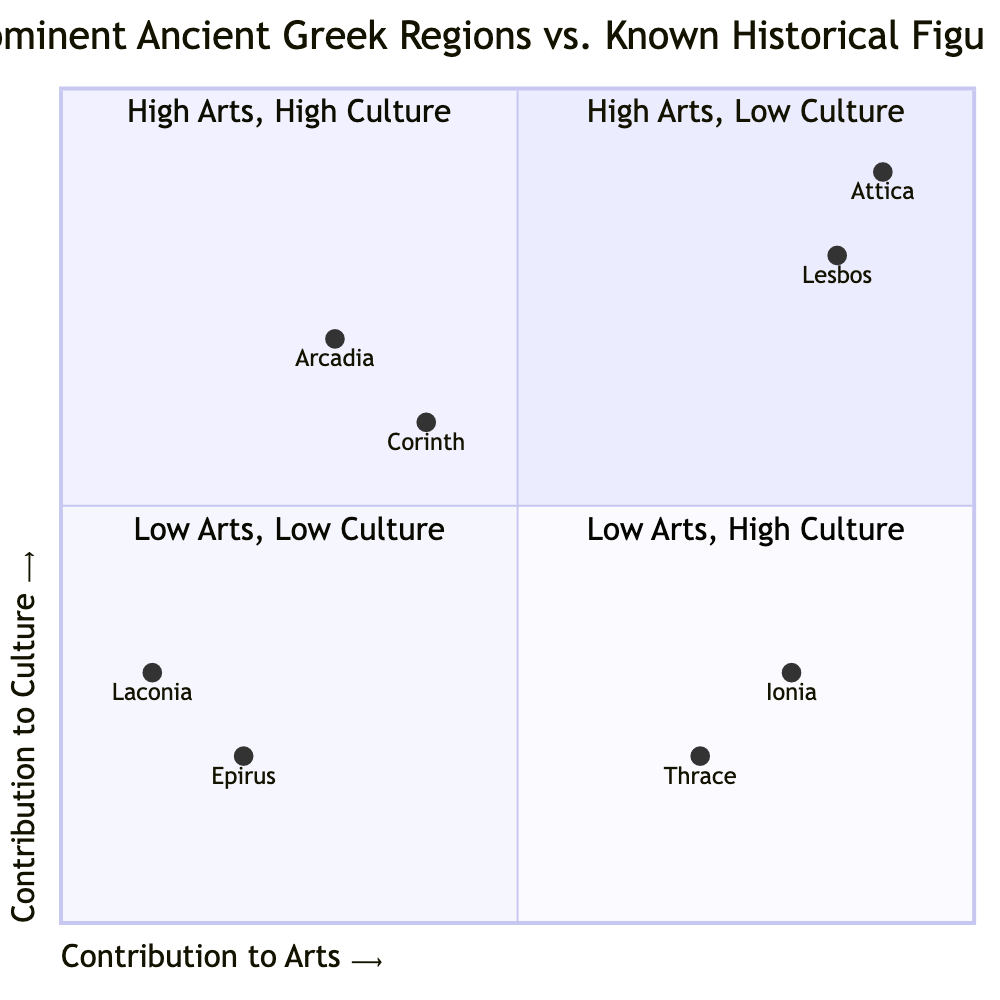What region has the highest contribution to arts? The region with the highest contribution to arts can be found in the top right quadrant. The example of Attica shows a contribution value of 0.9 in arts, which is the highest among all listed regions.
Answer: Attica Which historical figure is associated with the region of Ionia? In the top left quadrant under High Arts, Low Culture, the figure associated with Ionia is Homer. This information is provided in the descriptive examples of that quadrant.
Answer: Homer How many regions show high contributions to both arts and culture? By examining the top right quadrant, it can be noted that there are two regions (Attica and Lesbos) listed as having high contributions to both arts and culture.
Answer: 2 Which historical figure is noted for both cultural and artistic impact? The figure that stands out in both categories is Sophocles, listed in the top right quadrant, which specifically mentions his profound impact on both the dramatic arts and cultural narratives.
Answer: Sophocles In which quadrant does Pyrrhus belong? The quadrant where Pyrrhus is located can be determined by looking at the bottom left section of the diagram labeled Low Arts, Low Culture. This section contains the examples for that category.
Answer: Bottom left What is the contribution value for Corinth in terms of culture? The contribution value for Corinth regarding culture can be extracted from the bottom right quadrant, where it is specifically given as 0.6.
Answer: 0.6 Which region is known for low contributions in both arts and culture? The region known for low contributions in both areas is Epirus, which is located in the bottom left quadrant labeled Low Arts, Low Culture, where it is explicitly mentioned.
Answer: Epirus What is the defined title for the top right quadrant? By inspecting the labels provided for the quadrants, the title for the top right quadrant, which signifies high contributions to both arts and culture, is "High Arts, High Culture."
Answer: High Arts, High Culture Which region's historical figure is recognized for administrative achievements rather than artistic contributions? In the bottom right quadrant under Low Arts, High Culture, the historical figure Periander is recognized for his administrative accomplishments rather than his contributions to the arts.
Answer: Periander 